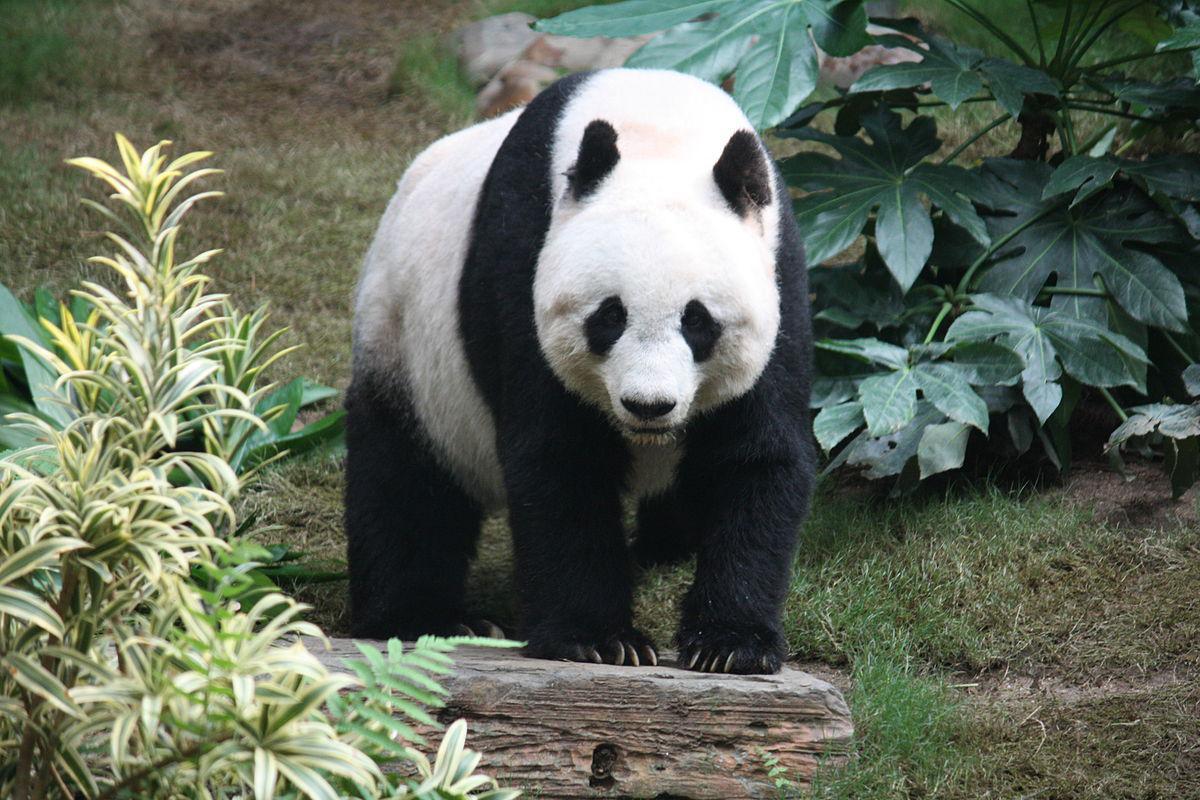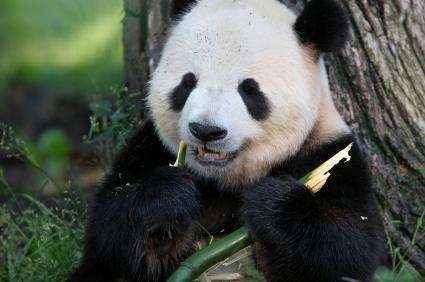The first image is the image on the left, the second image is the image on the right. Evaluate the accuracy of this statement regarding the images: "Only one image shows a panda munching on some type of foliage.". Is it true? Answer yes or no. Yes. 